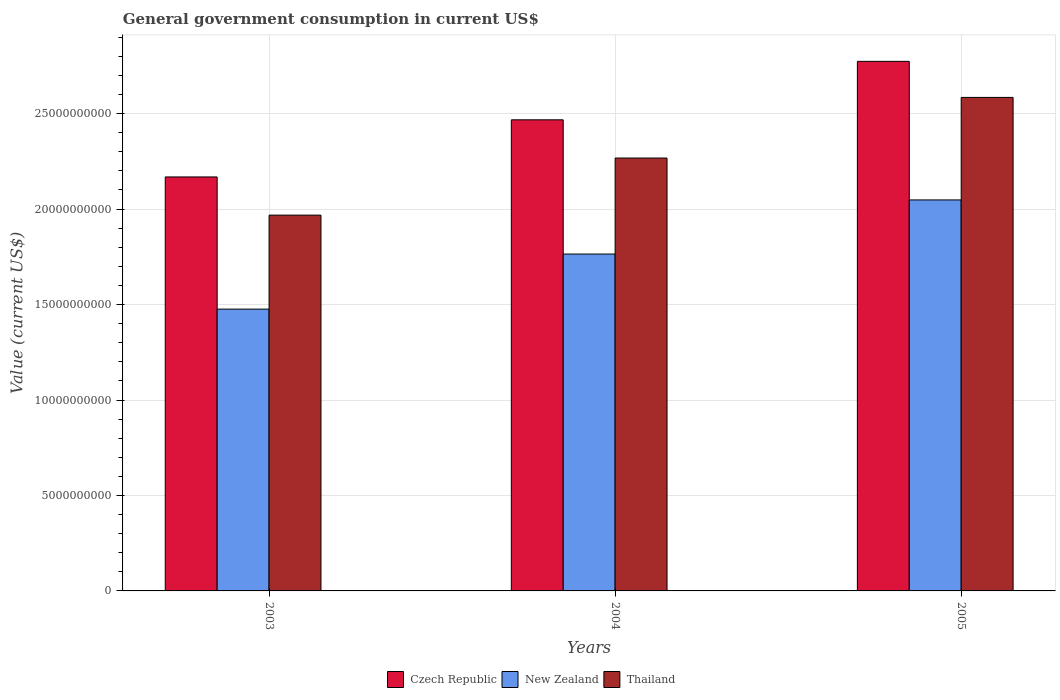Are the number of bars per tick equal to the number of legend labels?
Offer a very short reply. Yes. Are the number of bars on each tick of the X-axis equal?
Your answer should be very brief. Yes. How many bars are there on the 1st tick from the right?
Provide a succinct answer. 3. In how many cases, is the number of bars for a given year not equal to the number of legend labels?
Offer a very short reply. 0. What is the government conusmption in Thailand in 2004?
Give a very brief answer. 2.27e+1. Across all years, what is the maximum government conusmption in New Zealand?
Offer a terse response. 2.05e+1. Across all years, what is the minimum government conusmption in Thailand?
Your answer should be compact. 1.97e+1. In which year was the government conusmption in New Zealand maximum?
Keep it short and to the point. 2005. What is the total government conusmption in New Zealand in the graph?
Your answer should be compact. 5.29e+1. What is the difference between the government conusmption in Czech Republic in 2003 and that in 2005?
Your answer should be very brief. -6.05e+09. What is the difference between the government conusmption in Czech Republic in 2005 and the government conusmption in New Zealand in 2003?
Provide a succinct answer. 1.30e+1. What is the average government conusmption in Czech Republic per year?
Ensure brevity in your answer.  2.47e+1. In the year 2005, what is the difference between the government conusmption in Thailand and government conusmption in New Zealand?
Ensure brevity in your answer.  5.37e+09. In how many years, is the government conusmption in Czech Republic greater than 24000000000 US$?
Your answer should be very brief. 2. What is the ratio of the government conusmption in Czech Republic in 2003 to that in 2005?
Offer a very short reply. 0.78. Is the difference between the government conusmption in Thailand in 2003 and 2005 greater than the difference between the government conusmption in New Zealand in 2003 and 2005?
Keep it short and to the point. No. What is the difference between the highest and the second highest government conusmption in Czech Republic?
Offer a terse response. 3.06e+09. What is the difference between the highest and the lowest government conusmption in Thailand?
Give a very brief answer. 6.17e+09. In how many years, is the government conusmption in Thailand greater than the average government conusmption in Thailand taken over all years?
Provide a succinct answer. 1. What does the 3rd bar from the left in 2004 represents?
Your answer should be compact. Thailand. What does the 1st bar from the right in 2004 represents?
Offer a very short reply. Thailand. Is it the case that in every year, the sum of the government conusmption in New Zealand and government conusmption in Thailand is greater than the government conusmption in Czech Republic?
Your answer should be compact. Yes. How many bars are there?
Give a very brief answer. 9. Are all the bars in the graph horizontal?
Your answer should be very brief. No. How many years are there in the graph?
Your answer should be very brief. 3. Are the values on the major ticks of Y-axis written in scientific E-notation?
Ensure brevity in your answer.  No. What is the title of the graph?
Give a very brief answer. General government consumption in current US$. What is the label or title of the Y-axis?
Provide a short and direct response. Value (current US$). What is the Value (current US$) of Czech Republic in 2003?
Offer a very short reply. 2.17e+1. What is the Value (current US$) in New Zealand in 2003?
Your answer should be compact. 1.48e+1. What is the Value (current US$) of Thailand in 2003?
Your answer should be very brief. 1.97e+1. What is the Value (current US$) of Czech Republic in 2004?
Your answer should be compact. 2.47e+1. What is the Value (current US$) of New Zealand in 2004?
Keep it short and to the point. 1.76e+1. What is the Value (current US$) in Thailand in 2004?
Your response must be concise. 2.27e+1. What is the Value (current US$) in Czech Republic in 2005?
Ensure brevity in your answer.  2.77e+1. What is the Value (current US$) of New Zealand in 2005?
Provide a succinct answer. 2.05e+1. What is the Value (current US$) of Thailand in 2005?
Keep it short and to the point. 2.58e+1. Across all years, what is the maximum Value (current US$) in Czech Republic?
Provide a short and direct response. 2.77e+1. Across all years, what is the maximum Value (current US$) in New Zealand?
Offer a very short reply. 2.05e+1. Across all years, what is the maximum Value (current US$) in Thailand?
Your answer should be compact. 2.58e+1. Across all years, what is the minimum Value (current US$) of Czech Republic?
Offer a terse response. 2.17e+1. Across all years, what is the minimum Value (current US$) in New Zealand?
Provide a succinct answer. 1.48e+1. Across all years, what is the minimum Value (current US$) in Thailand?
Your answer should be very brief. 1.97e+1. What is the total Value (current US$) of Czech Republic in the graph?
Offer a terse response. 7.41e+1. What is the total Value (current US$) of New Zealand in the graph?
Provide a short and direct response. 5.29e+1. What is the total Value (current US$) of Thailand in the graph?
Offer a terse response. 6.82e+1. What is the difference between the Value (current US$) in Czech Republic in 2003 and that in 2004?
Your answer should be very brief. -2.99e+09. What is the difference between the Value (current US$) of New Zealand in 2003 and that in 2004?
Provide a succinct answer. -2.88e+09. What is the difference between the Value (current US$) of Thailand in 2003 and that in 2004?
Make the answer very short. -2.99e+09. What is the difference between the Value (current US$) of Czech Republic in 2003 and that in 2005?
Your response must be concise. -6.05e+09. What is the difference between the Value (current US$) of New Zealand in 2003 and that in 2005?
Give a very brief answer. -5.72e+09. What is the difference between the Value (current US$) of Thailand in 2003 and that in 2005?
Your answer should be very brief. -6.17e+09. What is the difference between the Value (current US$) of Czech Republic in 2004 and that in 2005?
Make the answer very short. -3.06e+09. What is the difference between the Value (current US$) in New Zealand in 2004 and that in 2005?
Your response must be concise. -2.83e+09. What is the difference between the Value (current US$) in Thailand in 2004 and that in 2005?
Your answer should be very brief. -3.18e+09. What is the difference between the Value (current US$) in Czech Republic in 2003 and the Value (current US$) in New Zealand in 2004?
Make the answer very short. 4.04e+09. What is the difference between the Value (current US$) of Czech Republic in 2003 and the Value (current US$) of Thailand in 2004?
Keep it short and to the point. -9.90e+08. What is the difference between the Value (current US$) of New Zealand in 2003 and the Value (current US$) of Thailand in 2004?
Your answer should be very brief. -7.91e+09. What is the difference between the Value (current US$) of Czech Republic in 2003 and the Value (current US$) of New Zealand in 2005?
Give a very brief answer. 1.20e+09. What is the difference between the Value (current US$) in Czech Republic in 2003 and the Value (current US$) in Thailand in 2005?
Make the answer very short. -4.17e+09. What is the difference between the Value (current US$) of New Zealand in 2003 and the Value (current US$) of Thailand in 2005?
Provide a succinct answer. -1.11e+1. What is the difference between the Value (current US$) of Czech Republic in 2004 and the Value (current US$) of New Zealand in 2005?
Offer a very short reply. 4.20e+09. What is the difference between the Value (current US$) in Czech Republic in 2004 and the Value (current US$) in Thailand in 2005?
Ensure brevity in your answer.  -1.17e+09. What is the difference between the Value (current US$) of New Zealand in 2004 and the Value (current US$) of Thailand in 2005?
Keep it short and to the point. -8.20e+09. What is the average Value (current US$) in Czech Republic per year?
Offer a terse response. 2.47e+1. What is the average Value (current US$) of New Zealand per year?
Keep it short and to the point. 1.76e+1. What is the average Value (current US$) in Thailand per year?
Your answer should be compact. 2.27e+1. In the year 2003, what is the difference between the Value (current US$) of Czech Republic and Value (current US$) of New Zealand?
Offer a terse response. 6.92e+09. In the year 2003, what is the difference between the Value (current US$) in Czech Republic and Value (current US$) in Thailand?
Your response must be concise. 2.00e+09. In the year 2003, what is the difference between the Value (current US$) in New Zealand and Value (current US$) in Thailand?
Keep it short and to the point. -4.92e+09. In the year 2004, what is the difference between the Value (current US$) in Czech Republic and Value (current US$) in New Zealand?
Provide a succinct answer. 7.03e+09. In the year 2004, what is the difference between the Value (current US$) in Czech Republic and Value (current US$) in Thailand?
Your response must be concise. 2.00e+09. In the year 2004, what is the difference between the Value (current US$) in New Zealand and Value (current US$) in Thailand?
Ensure brevity in your answer.  -5.03e+09. In the year 2005, what is the difference between the Value (current US$) in Czech Republic and Value (current US$) in New Zealand?
Make the answer very short. 7.26e+09. In the year 2005, what is the difference between the Value (current US$) in Czech Republic and Value (current US$) in Thailand?
Give a very brief answer. 1.89e+09. In the year 2005, what is the difference between the Value (current US$) of New Zealand and Value (current US$) of Thailand?
Make the answer very short. -5.37e+09. What is the ratio of the Value (current US$) of Czech Republic in 2003 to that in 2004?
Provide a succinct answer. 0.88. What is the ratio of the Value (current US$) in New Zealand in 2003 to that in 2004?
Offer a terse response. 0.84. What is the ratio of the Value (current US$) in Thailand in 2003 to that in 2004?
Your answer should be very brief. 0.87. What is the ratio of the Value (current US$) in Czech Republic in 2003 to that in 2005?
Your response must be concise. 0.78. What is the ratio of the Value (current US$) of New Zealand in 2003 to that in 2005?
Offer a terse response. 0.72. What is the ratio of the Value (current US$) of Thailand in 2003 to that in 2005?
Offer a very short reply. 0.76. What is the ratio of the Value (current US$) of Czech Republic in 2004 to that in 2005?
Offer a terse response. 0.89. What is the ratio of the Value (current US$) of New Zealand in 2004 to that in 2005?
Give a very brief answer. 0.86. What is the ratio of the Value (current US$) in Thailand in 2004 to that in 2005?
Provide a short and direct response. 0.88. What is the difference between the highest and the second highest Value (current US$) of Czech Republic?
Make the answer very short. 3.06e+09. What is the difference between the highest and the second highest Value (current US$) of New Zealand?
Provide a short and direct response. 2.83e+09. What is the difference between the highest and the second highest Value (current US$) of Thailand?
Make the answer very short. 3.18e+09. What is the difference between the highest and the lowest Value (current US$) in Czech Republic?
Ensure brevity in your answer.  6.05e+09. What is the difference between the highest and the lowest Value (current US$) of New Zealand?
Provide a short and direct response. 5.72e+09. What is the difference between the highest and the lowest Value (current US$) in Thailand?
Keep it short and to the point. 6.17e+09. 